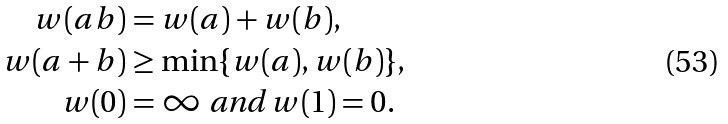<formula> <loc_0><loc_0><loc_500><loc_500>w ( a b ) & = w ( a ) + w ( b ) , \\ w ( a + b ) & \geq \min \{ w ( a ) , w ( b ) \} , \\ w ( 0 ) & = \infty \text { and } w ( 1 ) = 0 .</formula> 